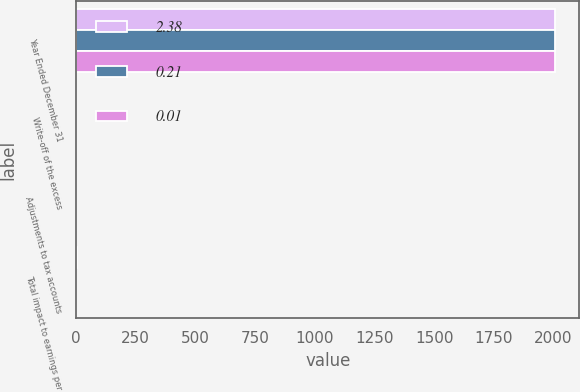Convert chart to OTSL. <chart><loc_0><loc_0><loc_500><loc_500><stacked_bar_chart><ecel><fcel>Year Ended December 31<fcel>Write-off of the excess<fcel>Adjustments to tax accounts<fcel>Total impact to earnings per<nl><fcel>2.38<fcel>2008<fcel>0.04<fcel>0.02<fcel>2.38<nl><fcel>0.21<fcel>2007<fcel>0.02<fcel>0.03<fcel>0.01<nl><fcel>0.01<fcel>2006<fcel>0.02<fcel>0.19<fcel>0.21<nl></chart> 